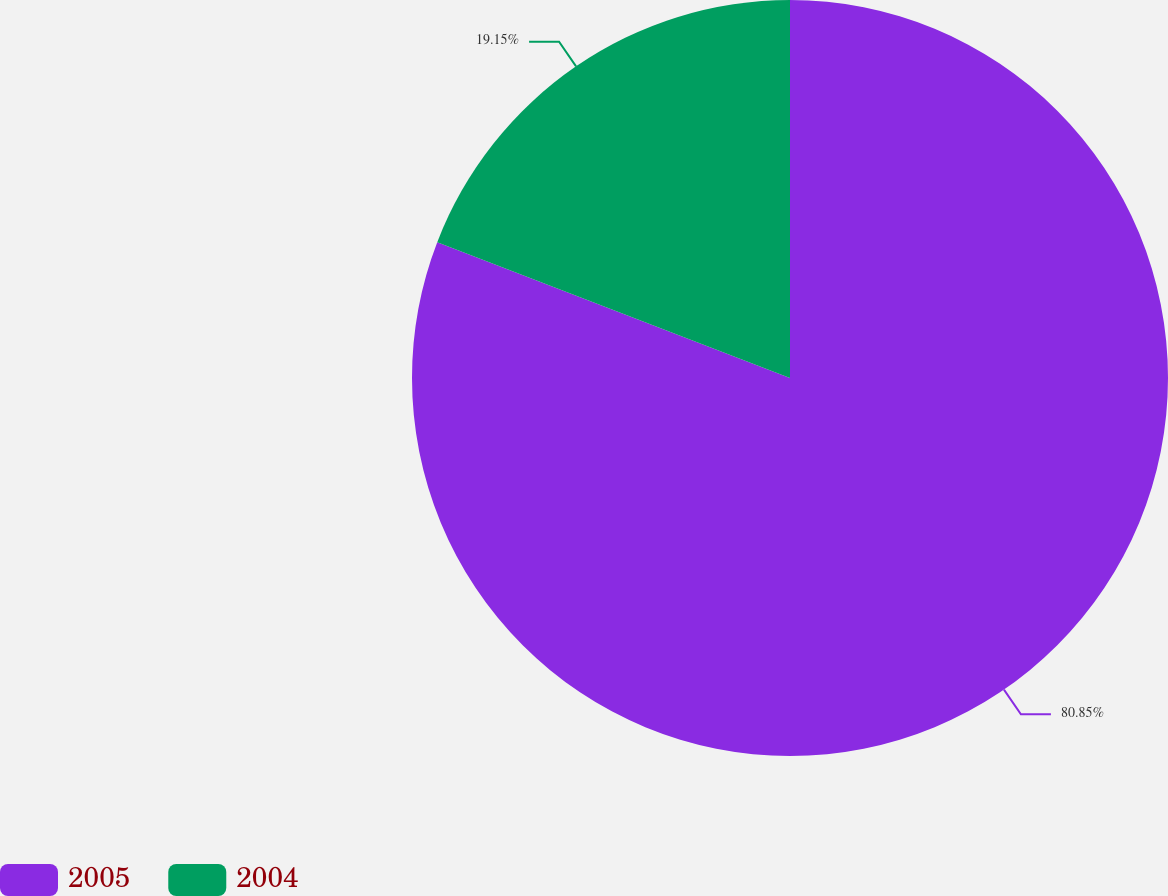Convert chart to OTSL. <chart><loc_0><loc_0><loc_500><loc_500><pie_chart><fcel>2005<fcel>2004<nl><fcel>80.85%<fcel>19.15%<nl></chart> 